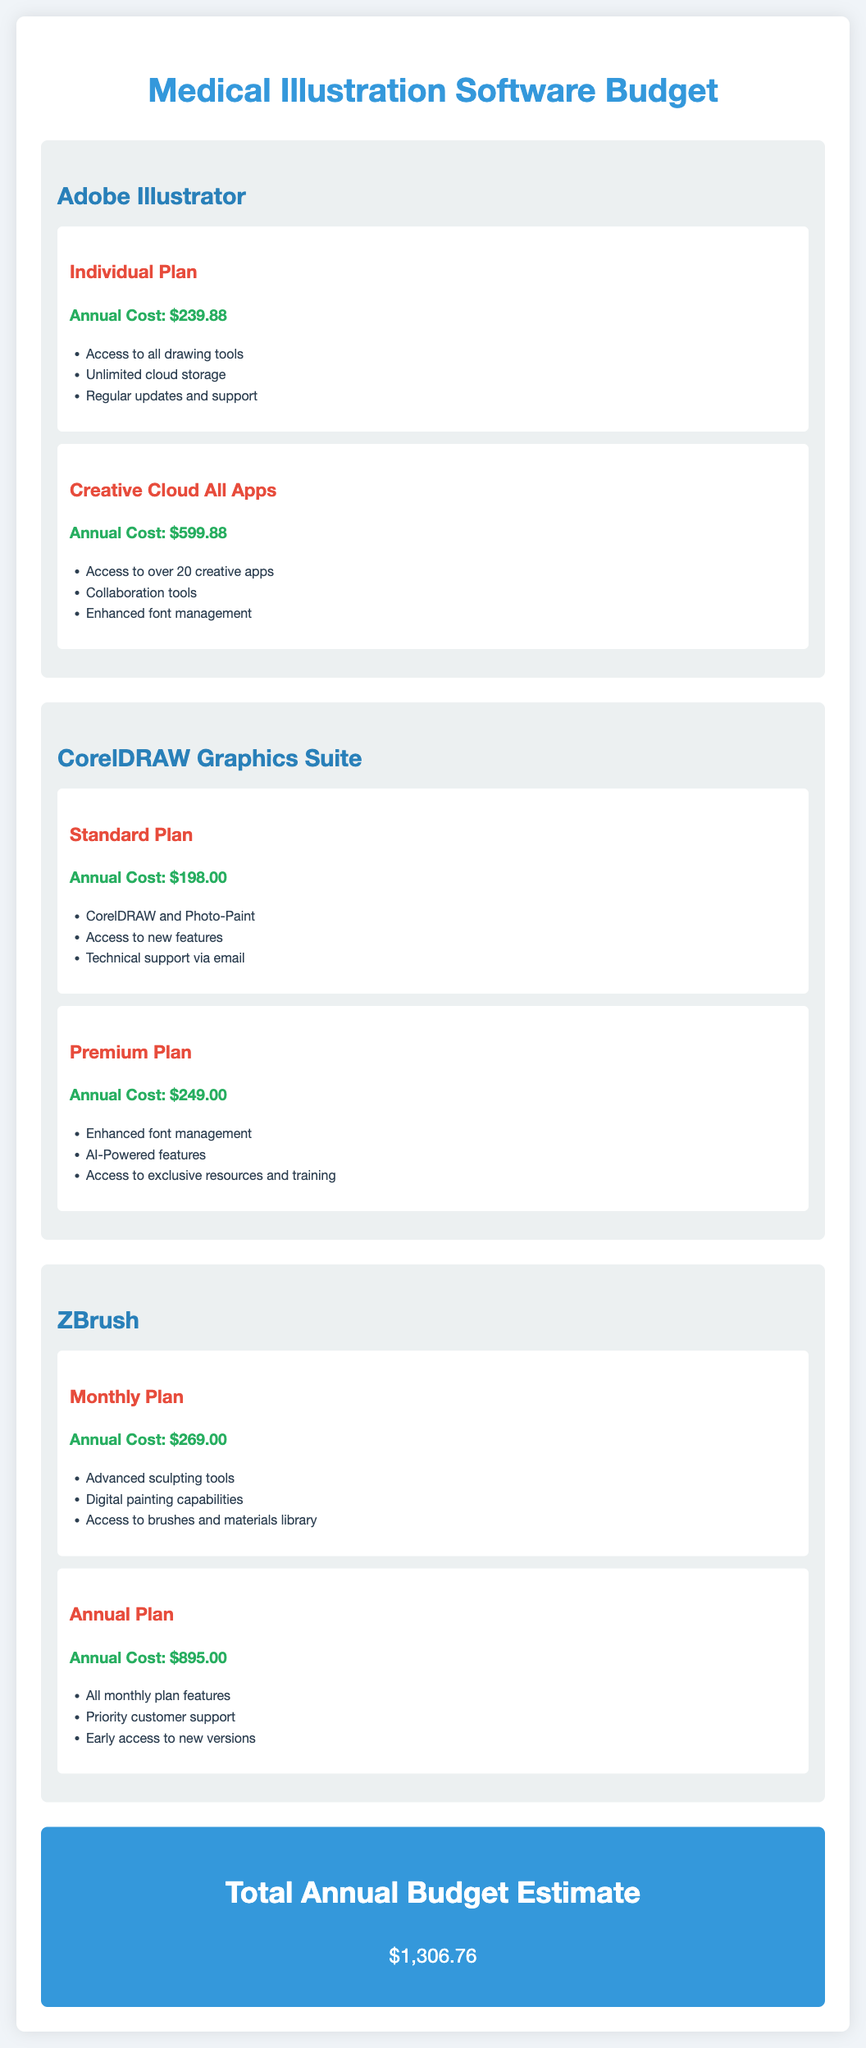What is the annual cost of Adobe Illustrator's Individual Plan? The annual cost of the Individual Plan for Adobe Illustrator is listed directly in the document.
Answer: $239.88 What features are included in the Premium Plan of CorelDRAW Graphics Suite? The features are outlined in a bullet list under the Premium Plan section.
Answer: Enhanced font management; AI-Powered features; Access to exclusive resources and training How many creative apps do you get with the Creative Cloud All Apps plan? The number of creative apps available in the Creative Cloud All Apps plan is mentioned in the document.
Answer: Over 20 What is the total annual budget estimate? The total annual budget is provided at the end of the document.
Answer: $1,306.76 Which software offers a Monthly Plan? This information requires identifying the software that provides a monthly subscription option.
Answer: ZBrush What type of support is provided with the Annual Plan of ZBrush? The type of support is mentioned in the features listed under the Annual Plan.
Answer: Priority customer support What is the annual cost of the Standard Plan in CorelDRAW Graphics Suite? The annual cost of the Standard Plan is specified in the document.
Answer: $198.00 What additional features does the Creative Cloud All Apps plan include compared to the Individual Plan? This requires comparing the features of both plans to determine the additional features.
Answer: Collaboration tools; Enhanced font management 